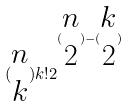Convert formula to latex. <formula><loc_0><loc_0><loc_500><loc_500>( \begin{matrix} n \\ k \end{matrix} ) k ! 2 ^ { ( \begin{matrix} n \\ 2 \end{matrix} ) - ( \begin{matrix} k \\ 2 \end{matrix} ) }</formula> 